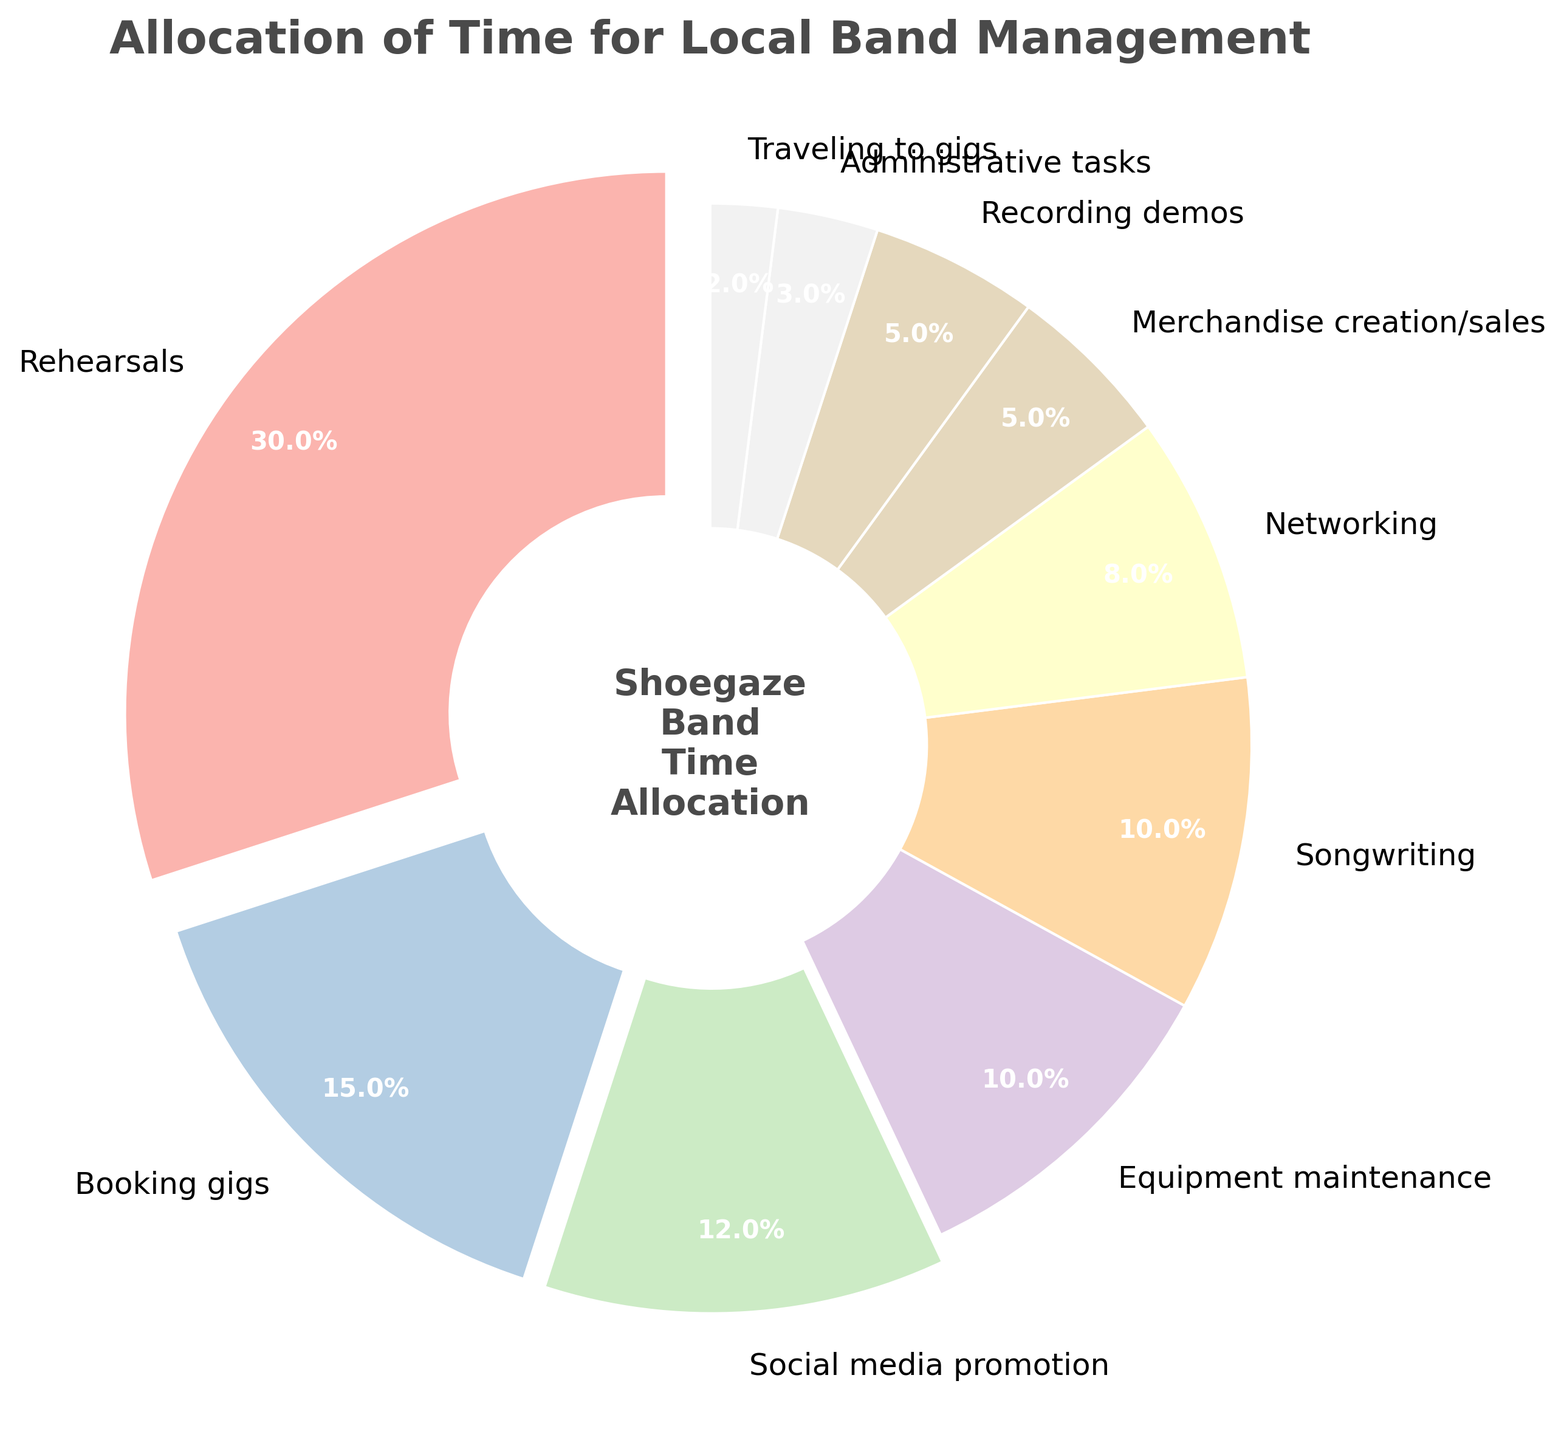What activity takes up the most time? Look at the largest slice of the pie chart, which has the highest percentage. In this case, the largest slice is for "Rehearsals" at 30%.
Answer: Rehearsals How much more time is spent on songwriting compared to traveling to gigs? Subtract the percentage for traveling to gigs from the percentage for songwriting. This is 10% (Songwriting) - 2% (Traveling to gigs) = 8%.
Answer: 8% Which two activities combined take up the same amount of time as rehearsals? Identify the two segments whose combined percentage equals that of rehearsals (30%). Booking gigs (15%) and social media promotion (12%) together account for 27%, while equipment maintenance (10%) and songwriting (10%) together account for 20%. Therefore, no two specific activities combined add up to exactly 30%.
Answer: None What percentage of time is spent on administrative tasks and equipment maintenance together? Add the percentage of time spent on administrative tasks (3%) and equipment maintenance (10%). This is 3% + 10% = 13%.
Answer: 13% Which activities are shown in the most similar shades of color? Refer to the visual attributes of the pie chart where similar shades might indicate similar activities close in percentage. Booking gigs and social media promotion appear in similar pastel shades.
Answer: Booking gigs and social media promotion How does the time spent on merchandise creation/sales compare with the time spent on recording demos? Compare the two pie chart segments. Both segments are the same size, each representing 5%.
Answer: Equal Which activity is allocated the least amount of time? Look for the smallest slice in the pie chart. The smallest slice is traveling to gigs, with 2%.
Answer: Traveling to gigs Is more time spent on networking or on songwriting? Compare the percentages for networking (8%) and songwriting (10%). Songwriting has a higher percentage.
Answer: Songwriting What is the total percentage of time spent on activities other than rehearsals and booking gigs? Subtract the combined total of rehearsals (30%) and booking gigs (15%) from 100%. This is 100% - (30% + 15%) = 55%.
Answer: 55% Which activities each consume more than 10% of the time? Look for segments with percentages greater than 10%. Rehearsals (30%), Booking gigs (15%), and Social media promotion (12%) each consume more than 10%.
Answer: Rehearsals, Booking gigs, Social media promotion 